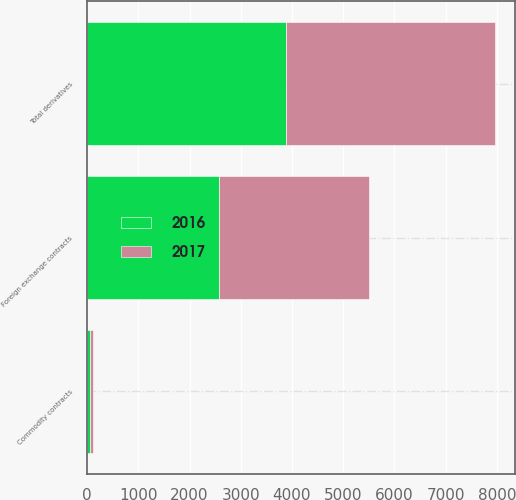<chart> <loc_0><loc_0><loc_500><loc_500><stacked_bar_chart><ecel><fcel>Foreign exchange contracts<fcel>Commodity contracts<fcel>Total derivatives<nl><fcel>2017<fcel>2930<fcel>56<fcel>4080<nl><fcel>2016<fcel>2584<fcel>53<fcel>3875<nl></chart> 